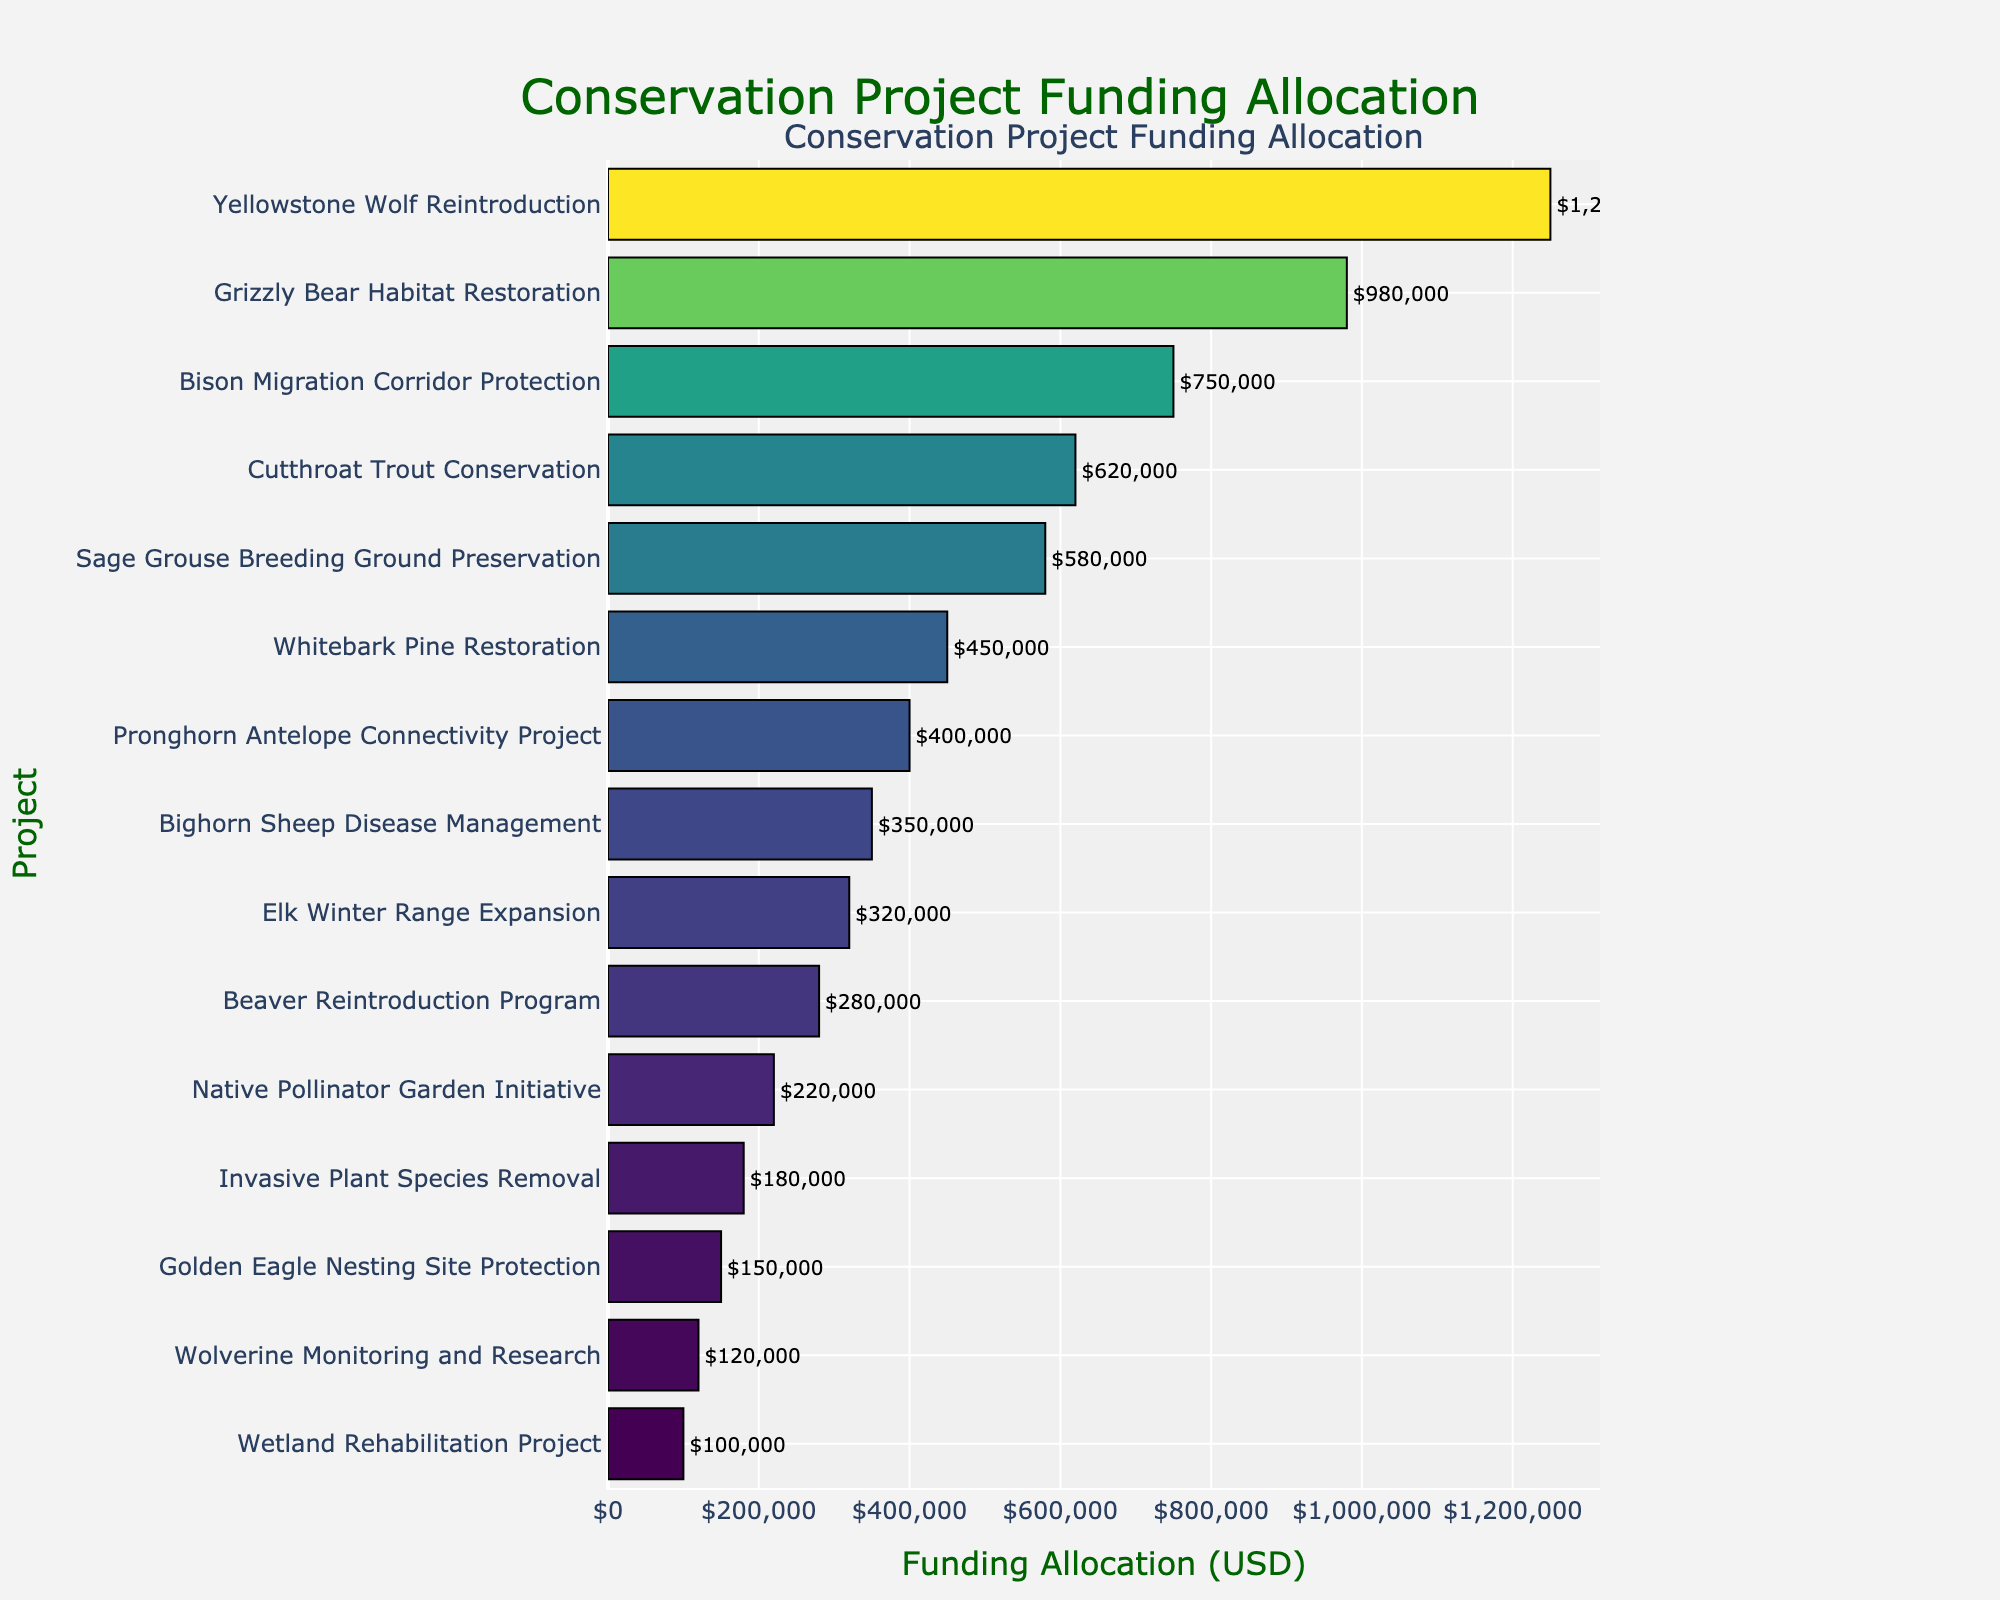Which project received the highest funding allocation? The project with the longest bar represents the highest funding allocation. The "Yellowstone Wolf Reintroduction" has the longest bar.
Answer: Yellowstone Wolf Reintroduction How much more funding did the "Grizzly Bear Habitat Restoration" receive compared to the "Wetland Rehabilitation Project"? Subtract the funding allocation of the "Wetland Rehabilitation Project" from that of the "Grizzly Bear Habitat Restoration" ($980,000 - $100,000).
Answer: $880,000 Which projects received more than $500,000 in funding? Identify the bars that extend beyond the $500,000 mark. The projects are "Yellowstone Wolf Reintroduction," "Grizzly Bear Habitat Restoration," "Bison Migration Corridor Protection," "Cutthroat Trout Conservation," and "Sage Grouse Breeding Ground Preservation."
Answer: Yellowstone Wolf Reintroduction, Grizzly Bear Habitat Restoration, Bison Migration Corridor Protection, Cutthroat Trout Conservation, Sage Grouse Breeding Ground Preservation What is the total combined funding allocation for the "Whitebark Pine Restoration" and "Beaver Reintroduction Program"? Add the funding allocations of "Whitebark Pine Restoration" ($450,000) and "Beaver Reintroduction Program" ($280,000).
Answer: $730,000 Which project received the least amount of funding? The project with the shortest bar represents the lowest funding allocation. The "Wetland Rehabilitation Project" has the shortest bar.
Answer: Wetland Rehabilitation Project Compare the funding allocation of the "Bighorn Sheep Disease Management" project to the "Native Pollinator Garden Initiative" project. Which one received more funding and by how much? Subtract the funding allocation of the "Native Pollinator Garden Initiative" from that of the "Bighorn Sheep Disease Management" ($350,000 - $220,000). "Bighorn Sheep Disease Management" received more funding.
Answer: $130,000 What is the average funding allocation of the projects receiving between $200,000 and $600,000? Identify the projects: "Beaver Reintroduction Program" ($280,000), "Native Pollinator Garden Initiative" ($220,000), "Invasive Plant Species Removal" ($180,000), "Golden Eagle Nesting Site Protection" ($150,000), and "Wolverine Monitoring and Research" ($120,000). Calculate the average: ($280,000 + $220,000 + $180,000 + $150,000 + $120,000) / 5.
Answer: $190,000 What is the funding allocation for the "Pronghorn Antelope Connectivity Project," and how does it visually compare to the "Elk Winter Range Expansion"? The "Pronghorn Antelope Connectivity Project" received $400,000, while the "Elk Winter Range Expansion" received $320,000. The bar for the Pronghorn Antelope Connectivity Project is longer.
Answer: $400,000; longer bar Calculate the difference in funding between the top-funded (Yellowstone Wolf Reintroduction) and lowest-funded (Wetland Rehabilitation Project) projects. Subtract the funding allocation of the "Wetland Rehabilitation Project" from that of the "Yellowstone Wolf Reintroduction" ($1,250,000 - $100,000).
Answer: $1,150,000 